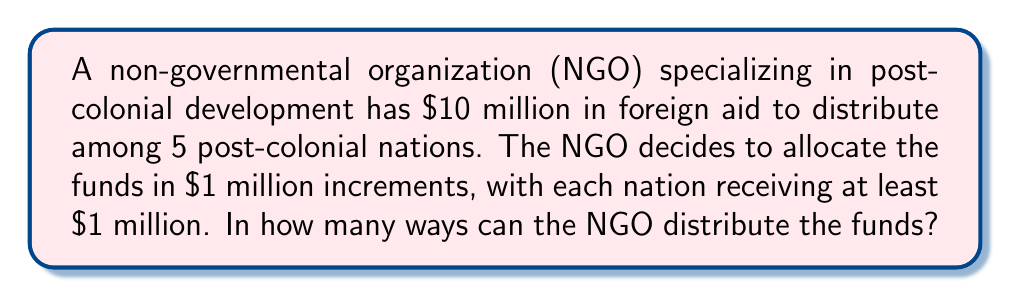Can you answer this question? This problem can be solved using the concept of combinations with repetition, also known as stars and bars.

1) First, we need to understand the setup:
   - We have $10 million to distribute
   - There are 5 nations
   - Each nation must receive at least $1 million
   - The remaining $5 million can be distributed in any way

2) We can think of this as distributing 5 stars (the remaining $5 million) among 5 bins (the nations), where we're allowed to put any number of stars in each bin, including zero.

3) The formula for combinations with repetition is:

   $${n+r-1 \choose r}$$

   Where $n$ is the number of bins and $r$ is the number of stars.

4) In this case:
   $n = 5$ (5 nations)
   $r = 5$ (5 remaining million-dollar increments)

5) Plugging these values into our formula:

   $${5+5-1 \choose 5} = {9 \choose 5}$$

6) We can calculate this:

   $${9 \choose 5} = \frac{9!}{5!(9-5)!} = \frac{9!}{5!4!}$$

7) Expanding this:

   $$\frac{9 * 8 * 7 * 6 * 5!}{5! * 4 * 3 * 2 * 1} = \frac{3024}{24} = 126$$

Therefore, there are 126 ways to distribute the funds.
Answer: 126 ways 